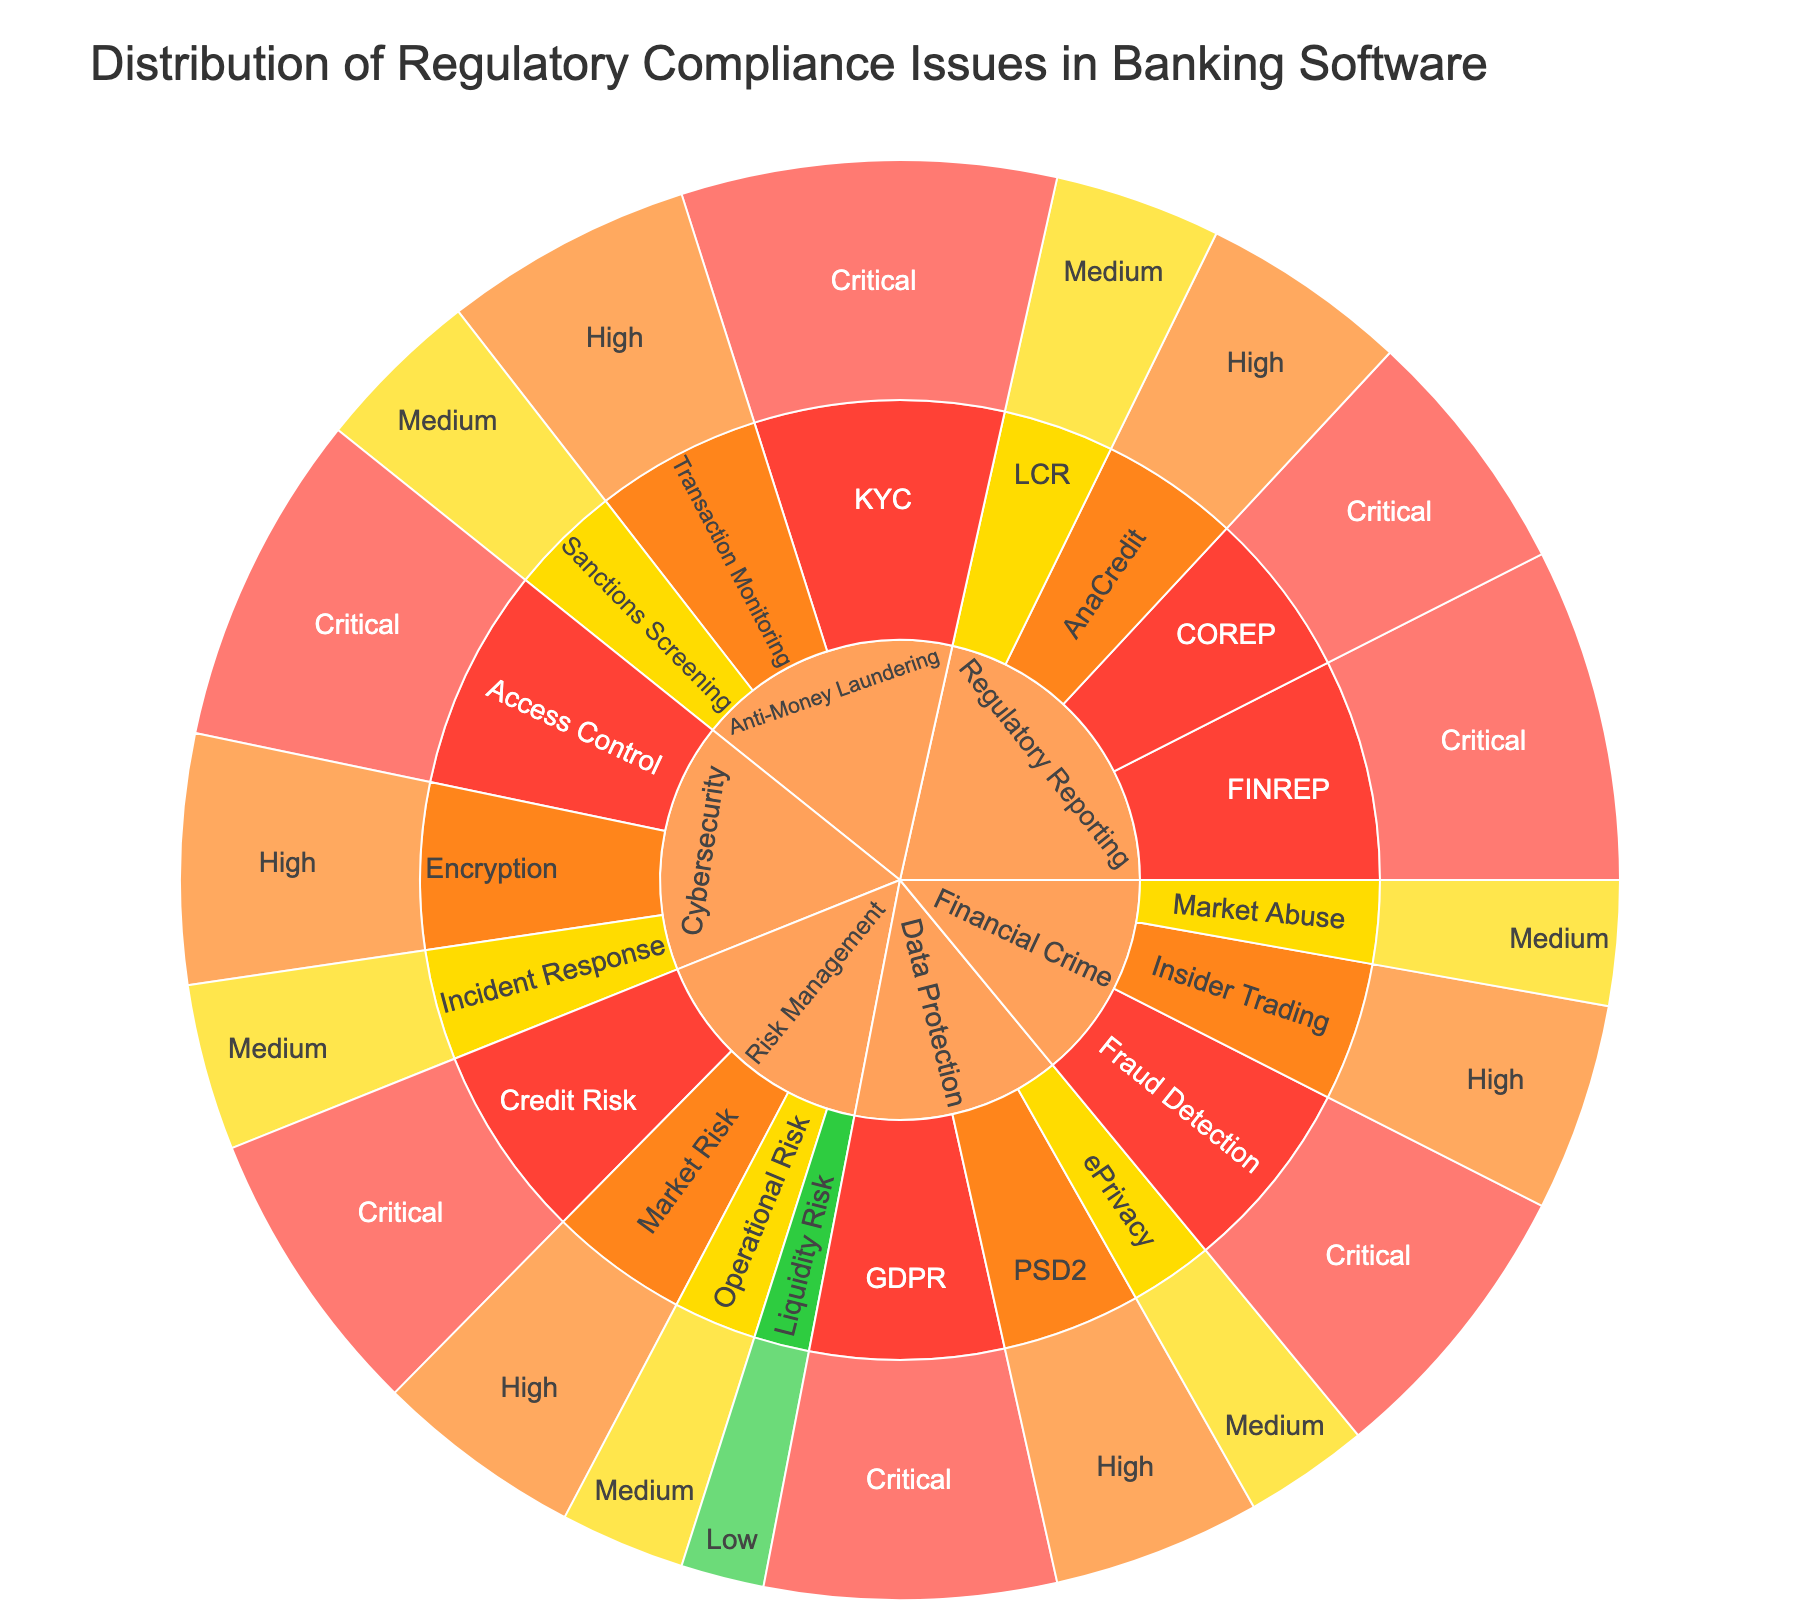what is the title of the plot? The title is usually found at the top of the plot. It provides a summary of what the plot represents. In this case, the title is about the distribution of regulatory compliance issues in banking software.
Answer: Distribution of Regulatory Compliance Issues in Banking Software What is the total number of "Critical" compliance issues in the "Anti-Money Laundering" category? To answer this, look at the segment labeled "Anti-Money Laundering" and find the "Critical" sections. Add the counts for the "KYC" under this severity level.
Answer: 9 Which category has the highest number of issues? To find this, add up the counts of issues for each category. The category with the highest total is your answer.
Answer: Anti-Money Laundering How many issues are there in the "Regulatory Reporting" category? Look under the "Regulatory Reporting" section and sum up all the values from its subcategories, regardless of severity.
Answer: 23 Compare the number of "Critical" issues between "Cybersecurity" and "Financial Crime". Which one has more? Look for the "Critical" segments under "Cybersecurity" and "Financial Crime" categories. Then compare the sums of their counts.
Answer: Cybersecurity What percentage of the total issues are considered "Low" severity? First, find the total number of issues (sum of all counts). Then find the sum of "Low" severity issues and divide by the total number. Multiply by 100 to get the percentage.
Answer: ~2.9% Which subcategory in "Risk Management" has the highest number of issues? Within the "Risk Management" section, compare the counts of each subcategory and identify the one with the maximum count.
Answer: Credit Risk How many "Medium" severity issues are in the "Data Protection" category? Look in the "Data Protection" section and sum the counts for the "Medium" severity issues.
Answer: 3 Compare the total number of issues in "Regulatory Reporting" and "Risk Management". Which category has fewer issues? Sum up the counts for each category and compare the totals to determine which one has fewer issues.
Answer: Risk Management What is the combined total count of "High" and "Medium" severity issues in the "Cybersecurity" category? Add the counts of "High" and "Medium" severity issues within the "Cybersecurity" section.
Answer: 10 